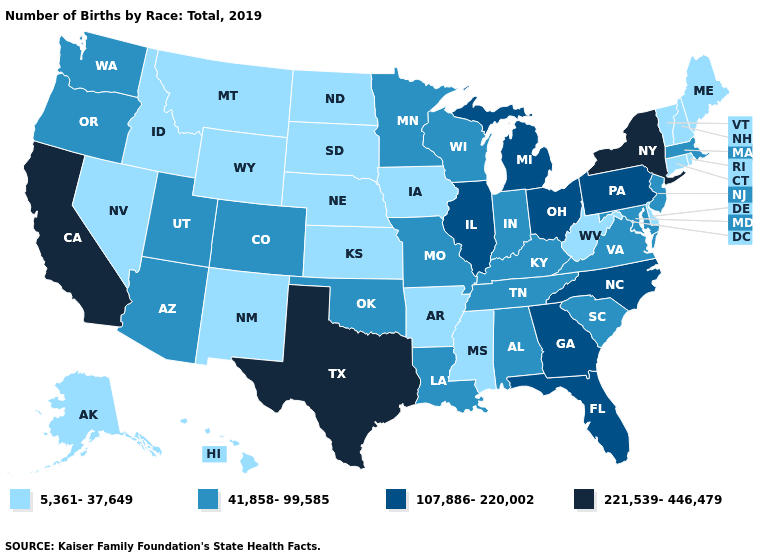What is the value of Rhode Island?
Keep it brief. 5,361-37,649. How many symbols are there in the legend?
Concise answer only. 4. What is the value of New York?
Concise answer only. 221,539-446,479. Which states have the lowest value in the USA?
Quick response, please. Alaska, Arkansas, Connecticut, Delaware, Hawaii, Idaho, Iowa, Kansas, Maine, Mississippi, Montana, Nebraska, Nevada, New Hampshire, New Mexico, North Dakota, Rhode Island, South Dakota, Vermont, West Virginia, Wyoming. What is the highest value in states that border Arkansas?
Concise answer only. 221,539-446,479. What is the highest value in the South ?
Keep it brief. 221,539-446,479. Does Georgia have the same value as Pennsylvania?
Be succinct. Yes. What is the value of Wyoming?
Short answer required. 5,361-37,649. What is the value of Kansas?
Concise answer only. 5,361-37,649. Is the legend a continuous bar?
Keep it brief. No. Does Maine have the lowest value in the Northeast?
Quick response, please. Yes. Name the states that have a value in the range 5,361-37,649?
Keep it brief. Alaska, Arkansas, Connecticut, Delaware, Hawaii, Idaho, Iowa, Kansas, Maine, Mississippi, Montana, Nebraska, Nevada, New Hampshire, New Mexico, North Dakota, Rhode Island, South Dakota, Vermont, West Virginia, Wyoming. Does New York have the highest value in the Northeast?
Answer briefly. Yes. Does the map have missing data?
Quick response, please. No. Among the states that border Minnesota , does Wisconsin have the highest value?
Short answer required. Yes. 